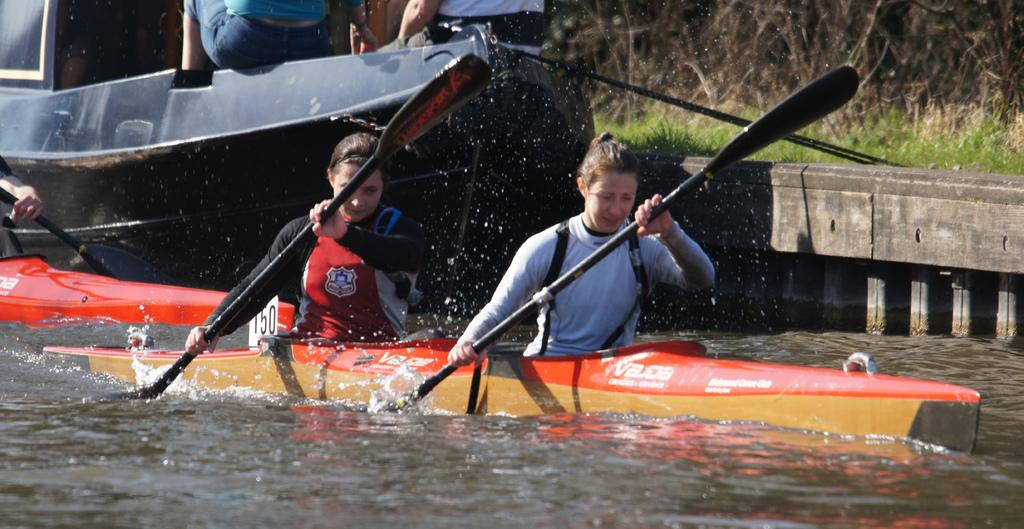How many people are in the image? There are two women in the image. What are the women doing in the image? The women are rowing a boat. Where is the boat located? The boat is in the water. What can be seen behind the boat? There is a ship behind the boat. What type of natural environment is visible in the background of the image? There is grass visible in the background of the image. What type of plantation can be seen in the image? There is no plantation present in the image. What architectural detail can be observed on the hall in the image? There is no hall present in the image. 